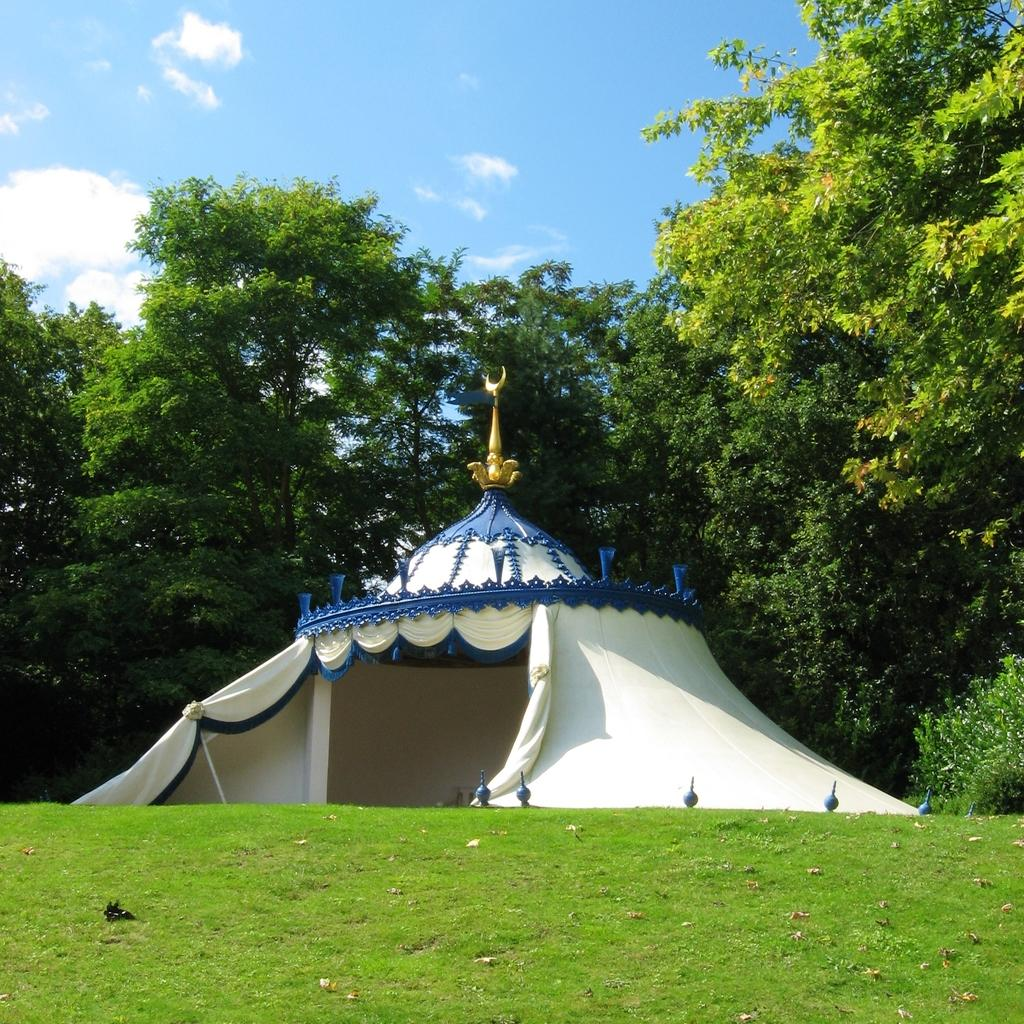What structure is located on the hill in the image? There is a tent on a hill in the image. What is on the tent in the image? There is a sculpture on the tent. What type of vegetation is on the ground in the image? There is grass on the ground in the image. What can be seen in the background of the image? There are trees and plants in the background of the image. What is visible at the top of the image? The sky is visible at the top of the image. What is the temperature in the image, and how does it affect the heart rate of the person inside the tent? The provided facts do not mention the temperature or any person inside the tent, so we cannot determine the temperature or its effect on a person's heart rate. 